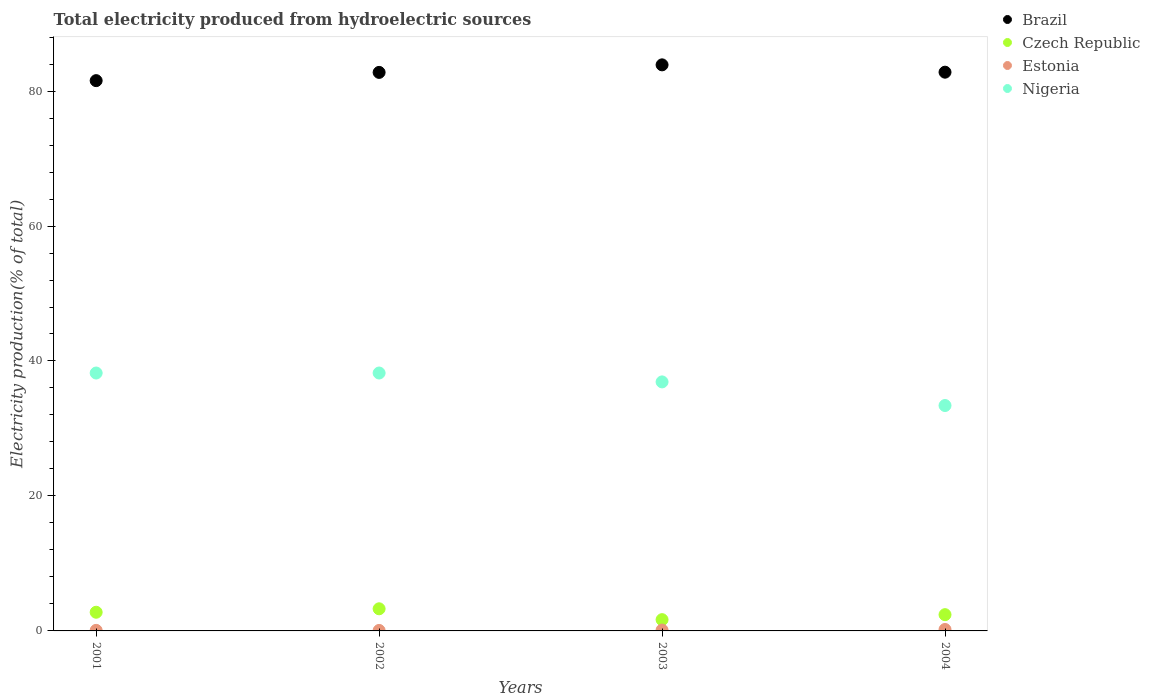How many different coloured dotlines are there?
Ensure brevity in your answer.  4. Is the number of dotlines equal to the number of legend labels?
Ensure brevity in your answer.  Yes. What is the total electricity produced in Brazil in 2004?
Ensure brevity in your answer.  82.8. Across all years, what is the maximum total electricity produced in Czech Republic?
Your response must be concise. 3.28. Across all years, what is the minimum total electricity produced in Nigeria?
Your response must be concise. 33.4. In which year was the total electricity produced in Nigeria maximum?
Give a very brief answer. 2002. What is the total total electricity produced in Czech Republic in the graph?
Offer a very short reply. 10.13. What is the difference between the total electricity produced in Estonia in 2002 and that in 2003?
Keep it short and to the point. -0.06. What is the difference between the total electricity produced in Estonia in 2003 and the total electricity produced in Czech Republic in 2001?
Offer a very short reply. -2.64. What is the average total electricity produced in Estonia per year?
Your answer should be compact. 0.12. In the year 2003, what is the difference between the total electricity produced in Brazil and total electricity produced in Czech Republic?
Give a very brief answer. 82.21. What is the ratio of the total electricity produced in Estonia in 2003 to that in 2004?
Provide a short and direct response. 0.6. What is the difference between the highest and the second highest total electricity produced in Nigeria?
Provide a succinct answer. 0. What is the difference between the highest and the lowest total electricity produced in Estonia?
Your answer should be compact. 0.14. Is the total electricity produced in Estonia strictly greater than the total electricity produced in Czech Republic over the years?
Provide a short and direct response. No. Is the total electricity produced in Estonia strictly less than the total electricity produced in Czech Republic over the years?
Keep it short and to the point. Yes. How many years are there in the graph?
Ensure brevity in your answer.  4. What is the difference between two consecutive major ticks on the Y-axis?
Provide a succinct answer. 20. Are the values on the major ticks of Y-axis written in scientific E-notation?
Provide a short and direct response. No. Does the graph contain any zero values?
Give a very brief answer. No. How are the legend labels stacked?
Provide a succinct answer. Vertical. What is the title of the graph?
Your answer should be very brief. Total electricity produced from hydroelectric sources. Does "Argentina" appear as one of the legend labels in the graph?
Your answer should be very brief. No. What is the Electricity production(% of total) in Brazil in 2001?
Offer a terse response. 81.54. What is the Electricity production(% of total) in Czech Republic in 2001?
Your answer should be very brief. 2.77. What is the Electricity production(% of total) of Estonia in 2001?
Your answer should be compact. 0.08. What is the Electricity production(% of total) of Nigeria in 2001?
Keep it short and to the point. 38.22. What is the Electricity production(% of total) of Brazil in 2002?
Provide a succinct answer. 82.76. What is the Electricity production(% of total) of Czech Republic in 2002?
Your response must be concise. 3.28. What is the Electricity production(% of total) in Estonia in 2002?
Make the answer very short. 0.07. What is the Electricity production(% of total) in Nigeria in 2002?
Offer a very short reply. 38.22. What is the Electricity production(% of total) of Brazil in 2003?
Make the answer very short. 83.88. What is the Electricity production(% of total) in Czech Republic in 2003?
Ensure brevity in your answer.  1.67. What is the Electricity production(% of total) in Estonia in 2003?
Keep it short and to the point. 0.13. What is the Electricity production(% of total) of Nigeria in 2003?
Provide a short and direct response. 36.9. What is the Electricity production(% of total) in Brazil in 2004?
Make the answer very short. 82.8. What is the Electricity production(% of total) in Czech Republic in 2004?
Offer a terse response. 2.41. What is the Electricity production(% of total) in Estonia in 2004?
Provide a short and direct response. 0.21. What is the Electricity production(% of total) of Nigeria in 2004?
Offer a terse response. 33.4. Across all years, what is the maximum Electricity production(% of total) in Brazil?
Give a very brief answer. 83.88. Across all years, what is the maximum Electricity production(% of total) of Czech Republic?
Offer a terse response. 3.28. Across all years, what is the maximum Electricity production(% of total) in Estonia?
Provide a short and direct response. 0.21. Across all years, what is the maximum Electricity production(% of total) in Nigeria?
Your answer should be very brief. 38.22. Across all years, what is the minimum Electricity production(% of total) of Brazil?
Your answer should be very brief. 81.54. Across all years, what is the minimum Electricity production(% of total) in Czech Republic?
Offer a terse response. 1.67. Across all years, what is the minimum Electricity production(% of total) in Estonia?
Your answer should be compact. 0.07. Across all years, what is the minimum Electricity production(% of total) in Nigeria?
Ensure brevity in your answer.  33.4. What is the total Electricity production(% of total) in Brazil in the graph?
Ensure brevity in your answer.  330.99. What is the total Electricity production(% of total) in Czech Republic in the graph?
Give a very brief answer. 10.13. What is the total Electricity production(% of total) of Estonia in the graph?
Give a very brief answer. 0.49. What is the total Electricity production(% of total) of Nigeria in the graph?
Give a very brief answer. 146.74. What is the difference between the Electricity production(% of total) of Brazil in 2001 and that in 2002?
Offer a very short reply. -1.22. What is the difference between the Electricity production(% of total) of Czech Republic in 2001 and that in 2002?
Give a very brief answer. -0.51. What is the difference between the Electricity production(% of total) of Estonia in 2001 and that in 2002?
Provide a succinct answer. 0.01. What is the difference between the Electricity production(% of total) in Nigeria in 2001 and that in 2002?
Keep it short and to the point. -0. What is the difference between the Electricity production(% of total) in Brazil in 2001 and that in 2003?
Provide a short and direct response. -2.34. What is the difference between the Electricity production(% of total) in Czech Republic in 2001 and that in 2003?
Make the answer very short. 1.1. What is the difference between the Electricity production(% of total) of Estonia in 2001 and that in 2003?
Ensure brevity in your answer.  -0.05. What is the difference between the Electricity production(% of total) in Nigeria in 2001 and that in 2003?
Give a very brief answer. 1.32. What is the difference between the Electricity production(% of total) of Brazil in 2001 and that in 2004?
Keep it short and to the point. -1.25. What is the difference between the Electricity production(% of total) of Czech Republic in 2001 and that in 2004?
Offer a terse response. 0.36. What is the difference between the Electricity production(% of total) of Estonia in 2001 and that in 2004?
Your answer should be compact. -0.13. What is the difference between the Electricity production(% of total) in Nigeria in 2001 and that in 2004?
Offer a very short reply. 4.82. What is the difference between the Electricity production(% of total) in Brazil in 2002 and that in 2003?
Your response must be concise. -1.12. What is the difference between the Electricity production(% of total) of Czech Republic in 2002 and that in 2003?
Your answer should be compact. 1.61. What is the difference between the Electricity production(% of total) in Estonia in 2002 and that in 2003?
Give a very brief answer. -0.06. What is the difference between the Electricity production(% of total) in Nigeria in 2002 and that in 2003?
Offer a terse response. 1.32. What is the difference between the Electricity production(% of total) in Brazil in 2002 and that in 2004?
Your answer should be compact. -0.03. What is the difference between the Electricity production(% of total) in Czech Republic in 2002 and that in 2004?
Your response must be concise. 0.87. What is the difference between the Electricity production(% of total) of Estonia in 2002 and that in 2004?
Your answer should be very brief. -0.14. What is the difference between the Electricity production(% of total) in Nigeria in 2002 and that in 2004?
Give a very brief answer. 4.82. What is the difference between the Electricity production(% of total) of Brazil in 2003 and that in 2004?
Ensure brevity in your answer.  1.09. What is the difference between the Electricity production(% of total) in Czech Republic in 2003 and that in 2004?
Your answer should be very brief. -0.74. What is the difference between the Electricity production(% of total) of Estonia in 2003 and that in 2004?
Provide a succinct answer. -0.09. What is the difference between the Electricity production(% of total) in Nigeria in 2003 and that in 2004?
Offer a very short reply. 3.5. What is the difference between the Electricity production(% of total) of Brazil in 2001 and the Electricity production(% of total) of Czech Republic in 2002?
Give a very brief answer. 78.26. What is the difference between the Electricity production(% of total) of Brazil in 2001 and the Electricity production(% of total) of Estonia in 2002?
Your answer should be compact. 81.47. What is the difference between the Electricity production(% of total) in Brazil in 2001 and the Electricity production(% of total) in Nigeria in 2002?
Keep it short and to the point. 43.33. What is the difference between the Electricity production(% of total) in Czech Republic in 2001 and the Electricity production(% of total) in Estonia in 2002?
Offer a very short reply. 2.7. What is the difference between the Electricity production(% of total) of Czech Republic in 2001 and the Electricity production(% of total) of Nigeria in 2002?
Keep it short and to the point. -35.45. What is the difference between the Electricity production(% of total) in Estonia in 2001 and the Electricity production(% of total) in Nigeria in 2002?
Give a very brief answer. -38.14. What is the difference between the Electricity production(% of total) of Brazil in 2001 and the Electricity production(% of total) of Czech Republic in 2003?
Give a very brief answer. 79.87. What is the difference between the Electricity production(% of total) of Brazil in 2001 and the Electricity production(% of total) of Estonia in 2003?
Your answer should be compact. 81.42. What is the difference between the Electricity production(% of total) of Brazil in 2001 and the Electricity production(% of total) of Nigeria in 2003?
Your answer should be compact. 44.64. What is the difference between the Electricity production(% of total) of Czech Republic in 2001 and the Electricity production(% of total) of Estonia in 2003?
Ensure brevity in your answer.  2.64. What is the difference between the Electricity production(% of total) in Czech Republic in 2001 and the Electricity production(% of total) in Nigeria in 2003?
Provide a short and direct response. -34.13. What is the difference between the Electricity production(% of total) of Estonia in 2001 and the Electricity production(% of total) of Nigeria in 2003?
Offer a very short reply. -36.82. What is the difference between the Electricity production(% of total) of Brazil in 2001 and the Electricity production(% of total) of Czech Republic in 2004?
Keep it short and to the point. 79.13. What is the difference between the Electricity production(% of total) of Brazil in 2001 and the Electricity production(% of total) of Estonia in 2004?
Offer a very short reply. 81.33. What is the difference between the Electricity production(% of total) of Brazil in 2001 and the Electricity production(% of total) of Nigeria in 2004?
Provide a succinct answer. 48.14. What is the difference between the Electricity production(% of total) in Czech Republic in 2001 and the Electricity production(% of total) in Estonia in 2004?
Provide a succinct answer. 2.55. What is the difference between the Electricity production(% of total) of Czech Republic in 2001 and the Electricity production(% of total) of Nigeria in 2004?
Your response must be concise. -30.63. What is the difference between the Electricity production(% of total) in Estonia in 2001 and the Electricity production(% of total) in Nigeria in 2004?
Make the answer very short. -33.32. What is the difference between the Electricity production(% of total) in Brazil in 2002 and the Electricity production(% of total) in Czech Republic in 2003?
Keep it short and to the point. 81.09. What is the difference between the Electricity production(% of total) in Brazil in 2002 and the Electricity production(% of total) in Estonia in 2003?
Make the answer very short. 82.64. What is the difference between the Electricity production(% of total) in Brazil in 2002 and the Electricity production(% of total) in Nigeria in 2003?
Offer a terse response. 45.86. What is the difference between the Electricity production(% of total) in Czech Republic in 2002 and the Electricity production(% of total) in Estonia in 2003?
Keep it short and to the point. 3.15. What is the difference between the Electricity production(% of total) of Czech Republic in 2002 and the Electricity production(% of total) of Nigeria in 2003?
Keep it short and to the point. -33.62. What is the difference between the Electricity production(% of total) of Estonia in 2002 and the Electricity production(% of total) of Nigeria in 2003?
Make the answer very short. -36.83. What is the difference between the Electricity production(% of total) of Brazil in 2002 and the Electricity production(% of total) of Czech Republic in 2004?
Offer a very short reply. 80.35. What is the difference between the Electricity production(% of total) in Brazil in 2002 and the Electricity production(% of total) in Estonia in 2004?
Keep it short and to the point. 82.55. What is the difference between the Electricity production(% of total) in Brazil in 2002 and the Electricity production(% of total) in Nigeria in 2004?
Make the answer very short. 49.36. What is the difference between the Electricity production(% of total) of Czech Republic in 2002 and the Electricity production(% of total) of Estonia in 2004?
Offer a very short reply. 3.07. What is the difference between the Electricity production(% of total) in Czech Republic in 2002 and the Electricity production(% of total) in Nigeria in 2004?
Your answer should be compact. -30.12. What is the difference between the Electricity production(% of total) of Estonia in 2002 and the Electricity production(% of total) of Nigeria in 2004?
Your answer should be compact. -33.33. What is the difference between the Electricity production(% of total) of Brazil in 2003 and the Electricity production(% of total) of Czech Republic in 2004?
Offer a terse response. 81.47. What is the difference between the Electricity production(% of total) in Brazil in 2003 and the Electricity production(% of total) in Estonia in 2004?
Your answer should be compact. 83.67. What is the difference between the Electricity production(% of total) in Brazil in 2003 and the Electricity production(% of total) in Nigeria in 2004?
Your response must be concise. 50.48. What is the difference between the Electricity production(% of total) in Czech Republic in 2003 and the Electricity production(% of total) in Estonia in 2004?
Your answer should be very brief. 1.46. What is the difference between the Electricity production(% of total) in Czech Republic in 2003 and the Electricity production(% of total) in Nigeria in 2004?
Offer a very short reply. -31.73. What is the difference between the Electricity production(% of total) in Estonia in 2003 and the Electricity production(% of total) in Nigeria in 2004?
Ensure brevity in your answer.  -33.27. What is the average Electricity production(% of total) of Brazil per year?
Provide a succinct answer. 82.75. What is the average Electricity production(% of total) in Czech Republic per year?
Make the answer very short. 2.53. What is the average Electricity production(% of total) in Estonia per year?
Provide a succinct answer. 0.12. What is the average Electricity production(% of total) in Nigeria per year?
Your answer should be compact. 36.68. In the year 2001, what is the difference between the Electricity production(% of total) of Brazil and Electricity production(% of total) of Czech Republic?
Provide a succinct answer. 78.78. In the year 2001, what is the difference between the Electricity production(% of total) of Brazil and Electricity production(% of total) of Estonia?
Offer a very short reply. 81.46. In the year 2001, what is the difference between the Electricity production(% of total) of Brazil and Electricity production(% of total) of Nigeria?
Offer a terse response. 43.33. In the year 2001, what is the difference between the Electricity production(% of total) in Czech Republic and Electricity production(% of total) in Estonia?
Your answer should be very brief. 2.68. In the year 2001, what is the difference between the Electricity production(% of total) of Czech Republic and Electricity production(% of total) of Nigeria?
Ensure brevity in your answer.  -35.45. In the year 2001, what is the difference between the Electricity production(% of total) of Estonia and Electricity production(% of total) of Nigeria?
Make the answer very short. -38.13. In the year 2002, what is the difference between the Electricity production(% of total) of Brazil and Electricity production(% of total) of Czech Republic?
Make the answer very short. 79.49. In the year 2002, what is the difference between the Electricity production(% of total) of Brazil and Electricity production(% of total) of Estonia?
Make the answer very short. 82.69. In the year 2002, what is the difference between the Electricity production(% of total) of Brazil and Electricity production(% of total) of Nigeria?
Offer a very short reply. 44.55. In the year 2002, what is the difference between the Electricity production(% of total) of Czech Republic and Electricity production(% of total) of Estonia?
Provide a short and direct response. 3.21. In the year 2002, what is the difference between the Electricity production(% of total) of Czech Republic and Electricity production(% of total) of Nigeria?
Provide a short and direct response. -34.94. In the year 2002, what is the difference between the Electricity production(% of total) in Estonia and Electricity production(% of total) in Nigeria?
Your response must be concise. -38.15. In the year 2003, what is the difference between the Electricity production(% of total) in Brazil and Electricity production(% of total) in Czech Republic?
Offer a terse response. 82.21. In the year 2003, what is the difference between the Electricity production(% of total) in Brazil and Electricity production(% of total) in Estonia?
Your answer should be compact. 83.75. In the year 2003, what is the difference between the Electricity production(% of total) in Brazil and Electricity production(% of total) in Nigeria?
Offer a terse response. 46.98. In the year 2003, what is the difference between the Electricity production(% of total) of Czech Republic and Electricity production(% of total) of Estonia?
Offer a terse response. 1.54. In the year 2003, what is the difference between the Electricity production(% of total) in Czech Republic and Electricity production(% of total) in Nigeria?
Your response must be concise. -35.23. In the year 2003, what is the difference between the Electricity production(% of total) in Estonia and Electricity production(% of total) in Nigeria?
Make the answer very short. -36.77. In the year 2004, what is the difference between the Electricity production(% of total) in Brazil and Electricity production(% of total) in Czech Republic?
Offer a very short reply. 80.39. In the year 2004, what is the difference between the Electricity production(% of total) of Brazil and Electricity production(% of total) of Estonia?
Offer a terse response. 82.58. In the year 2004, what is the difference between the Electricity production(% of total) of Brazil and Electricity production(% of total) of Nigeria?
Give a very brief answer. 49.4. In the year 2004, what is the difference between the Electricity production(% of total) in Czech Republic and Electricity production(% of total) in Estonia?
Offer a terse response. 2.2. In the year 2004, what is the difference between the Electricity production(% of total) of Czech Republic and Electricity production(% of total) of Nigeria?
Make the answer very short. -30.99. In the year 2004, what is the difference between the Electricity production(% of total) in Estonia and Electricity production(% of total) in Nigeria?
Provide a short and direct response. -33.19. What is the ratio of the Electricity production(% of total) in Brazil in 2001 to that in 2002?
Your answer should be very brief. 0.99. What is the ratio of the Electricity production(% of total) in Czech Republic in 2001 to that in 2002?
Your answer should be compact. 0.84. What is the ratio of the Electricity production(% of total) of Estonia in 2001 to that in 2002?
Offer a terse response. 1.17. What is the ratio of the Electricity production(% of total) of Brazil in 2001 to that in 2003?
Your response must be concise. 0.97. What is the ratio of the Electricity production(% of total) of Czech Republic in 2001 to that in 2003?
Your response must be concise. 1.66. What is the ratio of the Electricity production(% of total) in Estonia in 2001 to that in 2003?
Keep it short and to the point. 0.64. What is the ratio of the Electricity production(% of total) in Nigeria in 2001 to that in 2003?
Offer a very short reply. 1.04. What is the ratio of the Electricity production(% of total) in Brazil in 2001 to that in 2004?
Provide a succinct answer. 0.98. What is the ratio of the Electricity production(% of total) of Czech Republic in 2001 to that in 2004?
Offer a terse response. 1.15. What is the ratio of the Electricity production(% of total) of Estonia in 2001 to that in 2004?
Offer a very short reply. 0.39. What is the ratio of the Electricity production(% of total) of Nigeria in 2001 to that in 2004?
Ensure brevity in your answer.  1.14. What is the ratio of the Electricity production(% of total) of Brazil in 2002 to that in 2003?
Offer a terse response. 0.99. What is the ratio of the Electricity production(% of total) in Czech Republic in 2002 to that in 2003?
Make the answer very short. 1.96. What is the ratio of the Electricity production(% of total) of Estonia in 2002 to that in 2003?
Provide a succinct answer. 0.55. What is the ratio of the Electricity production(% of total) of Nigeria in 2002 to that in 2003?
Your answer should be compact. 1.04. What is the ratio of the Electricity production(% of total) in Brazil in 2002 to that in 2004?
Your answer should be very brief. 1. What is the ratio of the Electricity production(% of total) of Czech Republic in 2002 to that in 2004?
Your answer should be compact. 1.36. What is the ratio of the Electricity production(% of total) in Estonia in 2002 to that in 2004?
Your response must be concise. 0.33. What is the ratio of the Electricity production(% of total) in Nigeria in 2002 to that in 2004?
Your answer should be very brief. 1.14. What is the ratio of the Electricity production(% of total) of Brazil in 2003 to that in 2004?
Make the answer very short. 1.01. What is the ratio of the Electricity production(% of total) of Czech Republic in 2003 to that in 2004?
Your answer should be compact. 0.69. What is the ratio of the Electricity production(% of total) of Estonia in 2003 to that in 2004?
Offer a terse response. 0.6. What is the ratio of the Electricity production(% of total) in Nigeria in 2003 to that in 2004?
Ensure brevity in your answer.  1.1. What is the difference between the highest and the second highest Electricity production(% of total) in Brazil?
Ensure brevity in your answer.  1.09. What is the difference between the highest and the second highest Electricity production(% of total) of Czech Republic?
Keep it short and to the point. 0.51. What is the difference between the highest and the second highest Electricity production(% of total) of Estonia?
Provide a succinct answer. 0.09. What is the difference between the highest and the second highest Electricity production(% of total) of Nigeria?
Ensure brevity in your answer.  0. What is the difference between the highest and the lowest Electricity production(% of total) of Brazil?
Give a very brief answer. 2.34. What is the difference between the highest and the lowest Electricity production(% of total) in Czech Republic?
Make the answer very short. 1.61. What is the difference between the highest and the lowest Electricity production(% of total) in Estonia?
Offer a terse response. 0.14. What is the difference between the highest and the lowest Electricity production(% of total) in Nigeria?
Offer a very short reply. 4.82. 